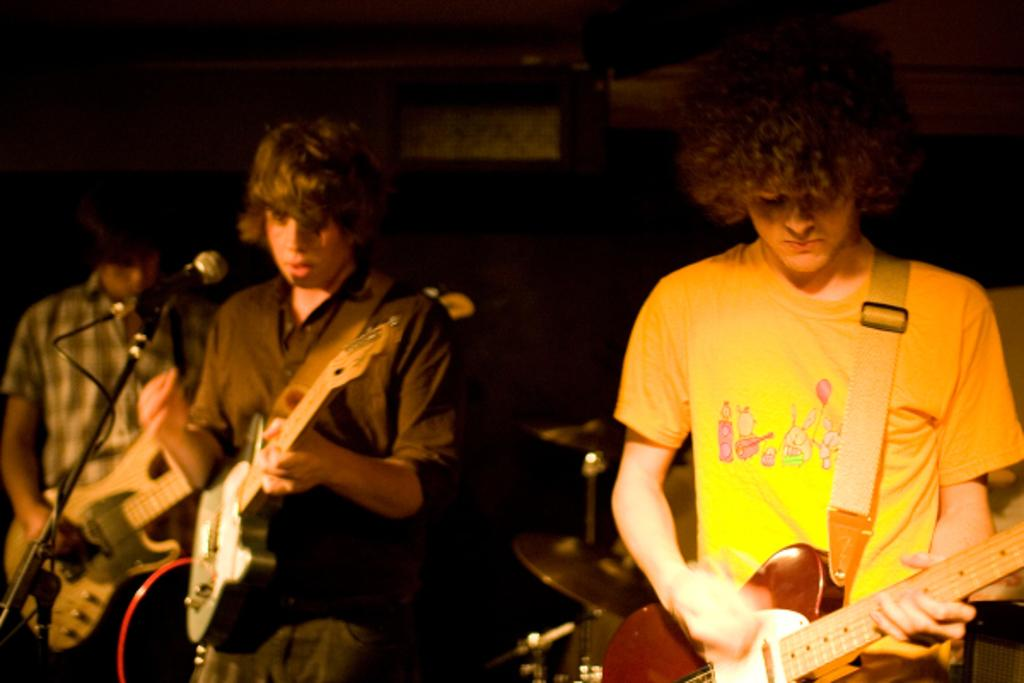How many people are in the image? There are three people in the image. What are the people doing in the image? The people are playing the guitar. What type of meat is being served with the fork in the image? There is no fork or meat present in the image; the people are playing the guitar. 